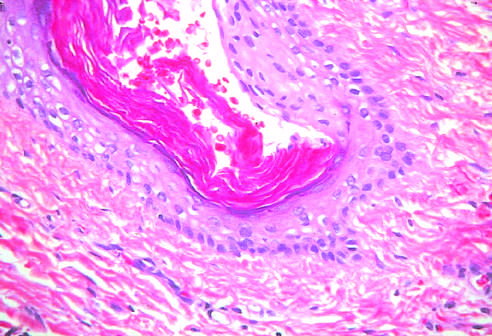what do testicular teratomas contain?
Answer the question using a single word or phrase. Mature cells from endodermal 